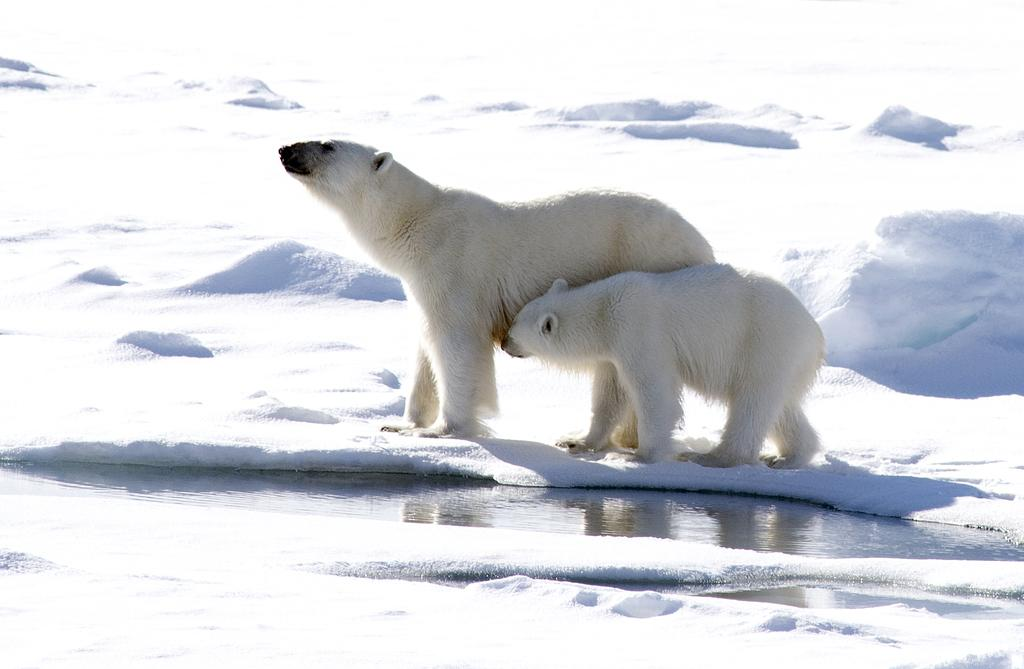What animals are in the center of the image? There are two bears in the center of the image. What is located at the bottom side of the image? There is water at the bottom side of the image. What type of weather is suggested by the presence of snow in the image? The presence of snow suggests cold weather in the image. What type of rhythm can be observed in the bears' movements in the image? There is no indication of movement or rhythm in the bears' actions in the image. 